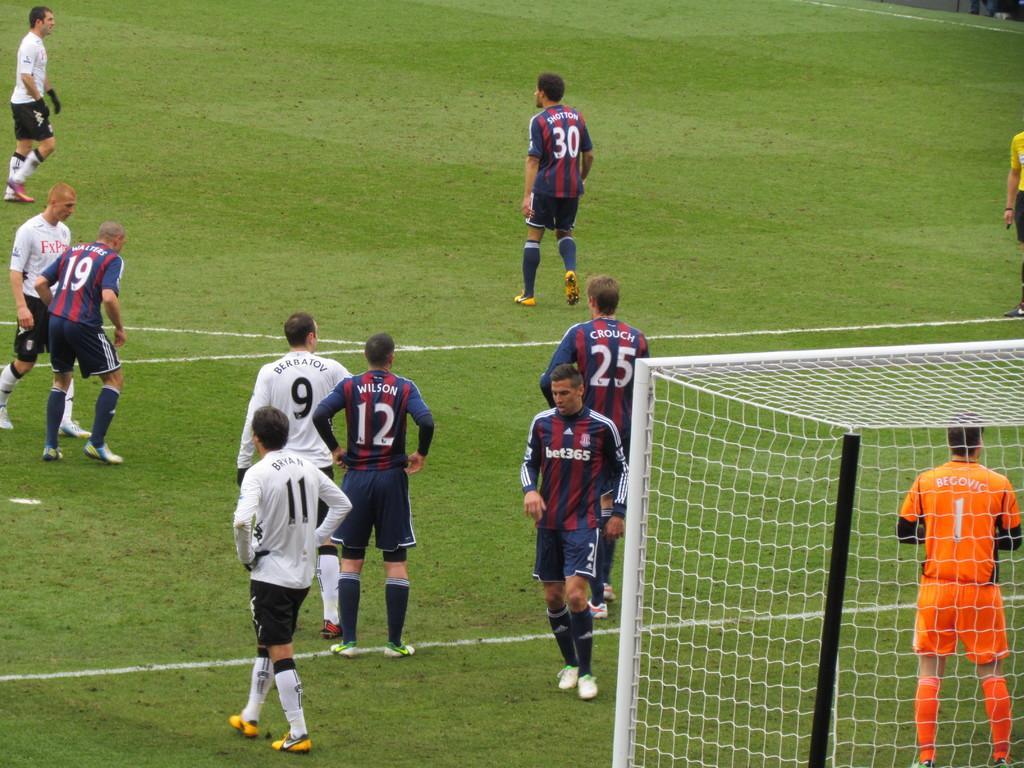Describe this image in one or two sentences. This picture describes about group of people, few are standing and few are walking on the grass, and also we can see few metal rods and a net. 